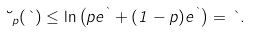Convert formula to latex. <formula><loc_0><loc_0><loc_500><loc_500>\lambda _ { p } ( \theta ) \leq \ln \left ( p e ^ { \theta } + ( 1 - p ) e ^ { \theta } \right ) = \theta .</formula> 